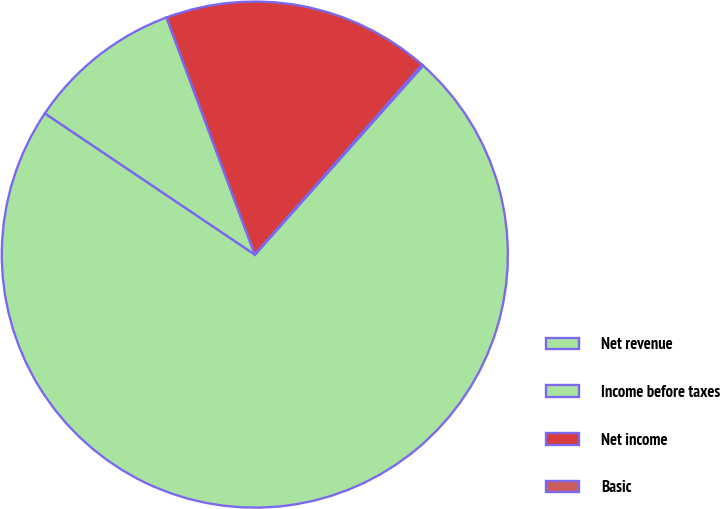<chart> <loc_0><loc_0><loc_500><loc_500><pie_chart><fcel>Net revenue<fcel>Income before taxes<fcel>Net income<fcel>Basic<nl><fcel>72.85%<fcel>9.9%<fcel>17.17%<fcel>0.08%<nl></chart> 